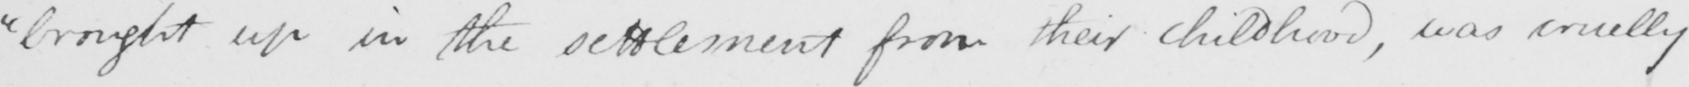What is written in this line of handwriting? "brought up in the settlement from their childhood, was cruelly 